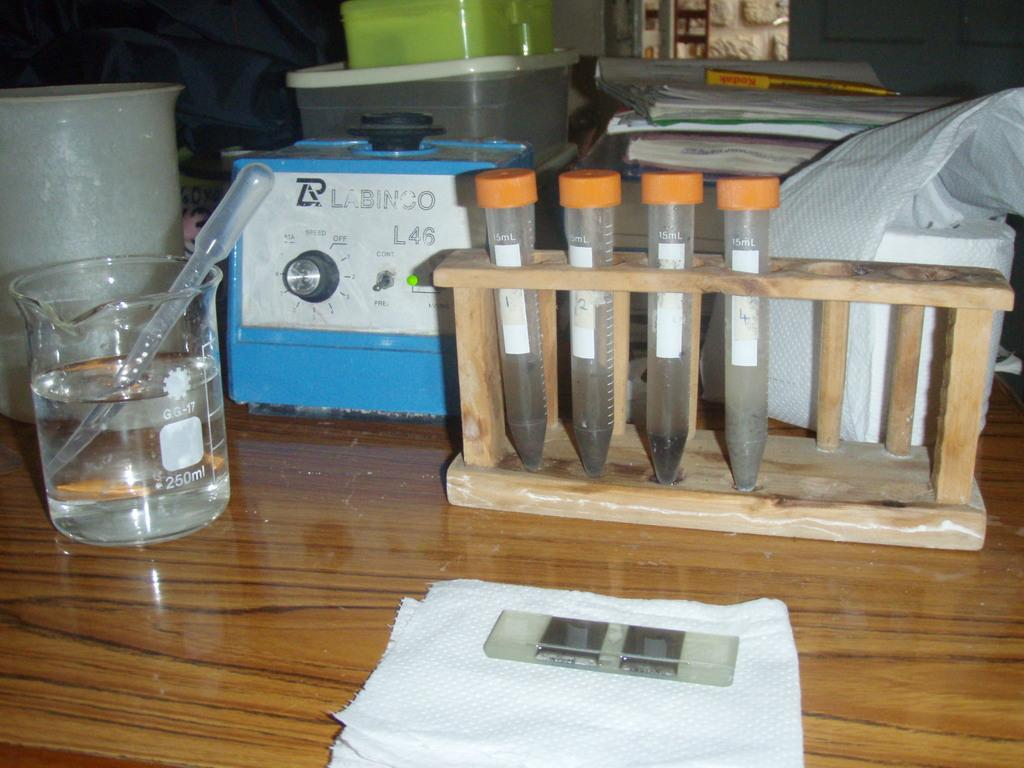<image>
Relay a brief, clear account of the picture shown. Test tubes are numbered one through four next to a 250ml cylinder. 